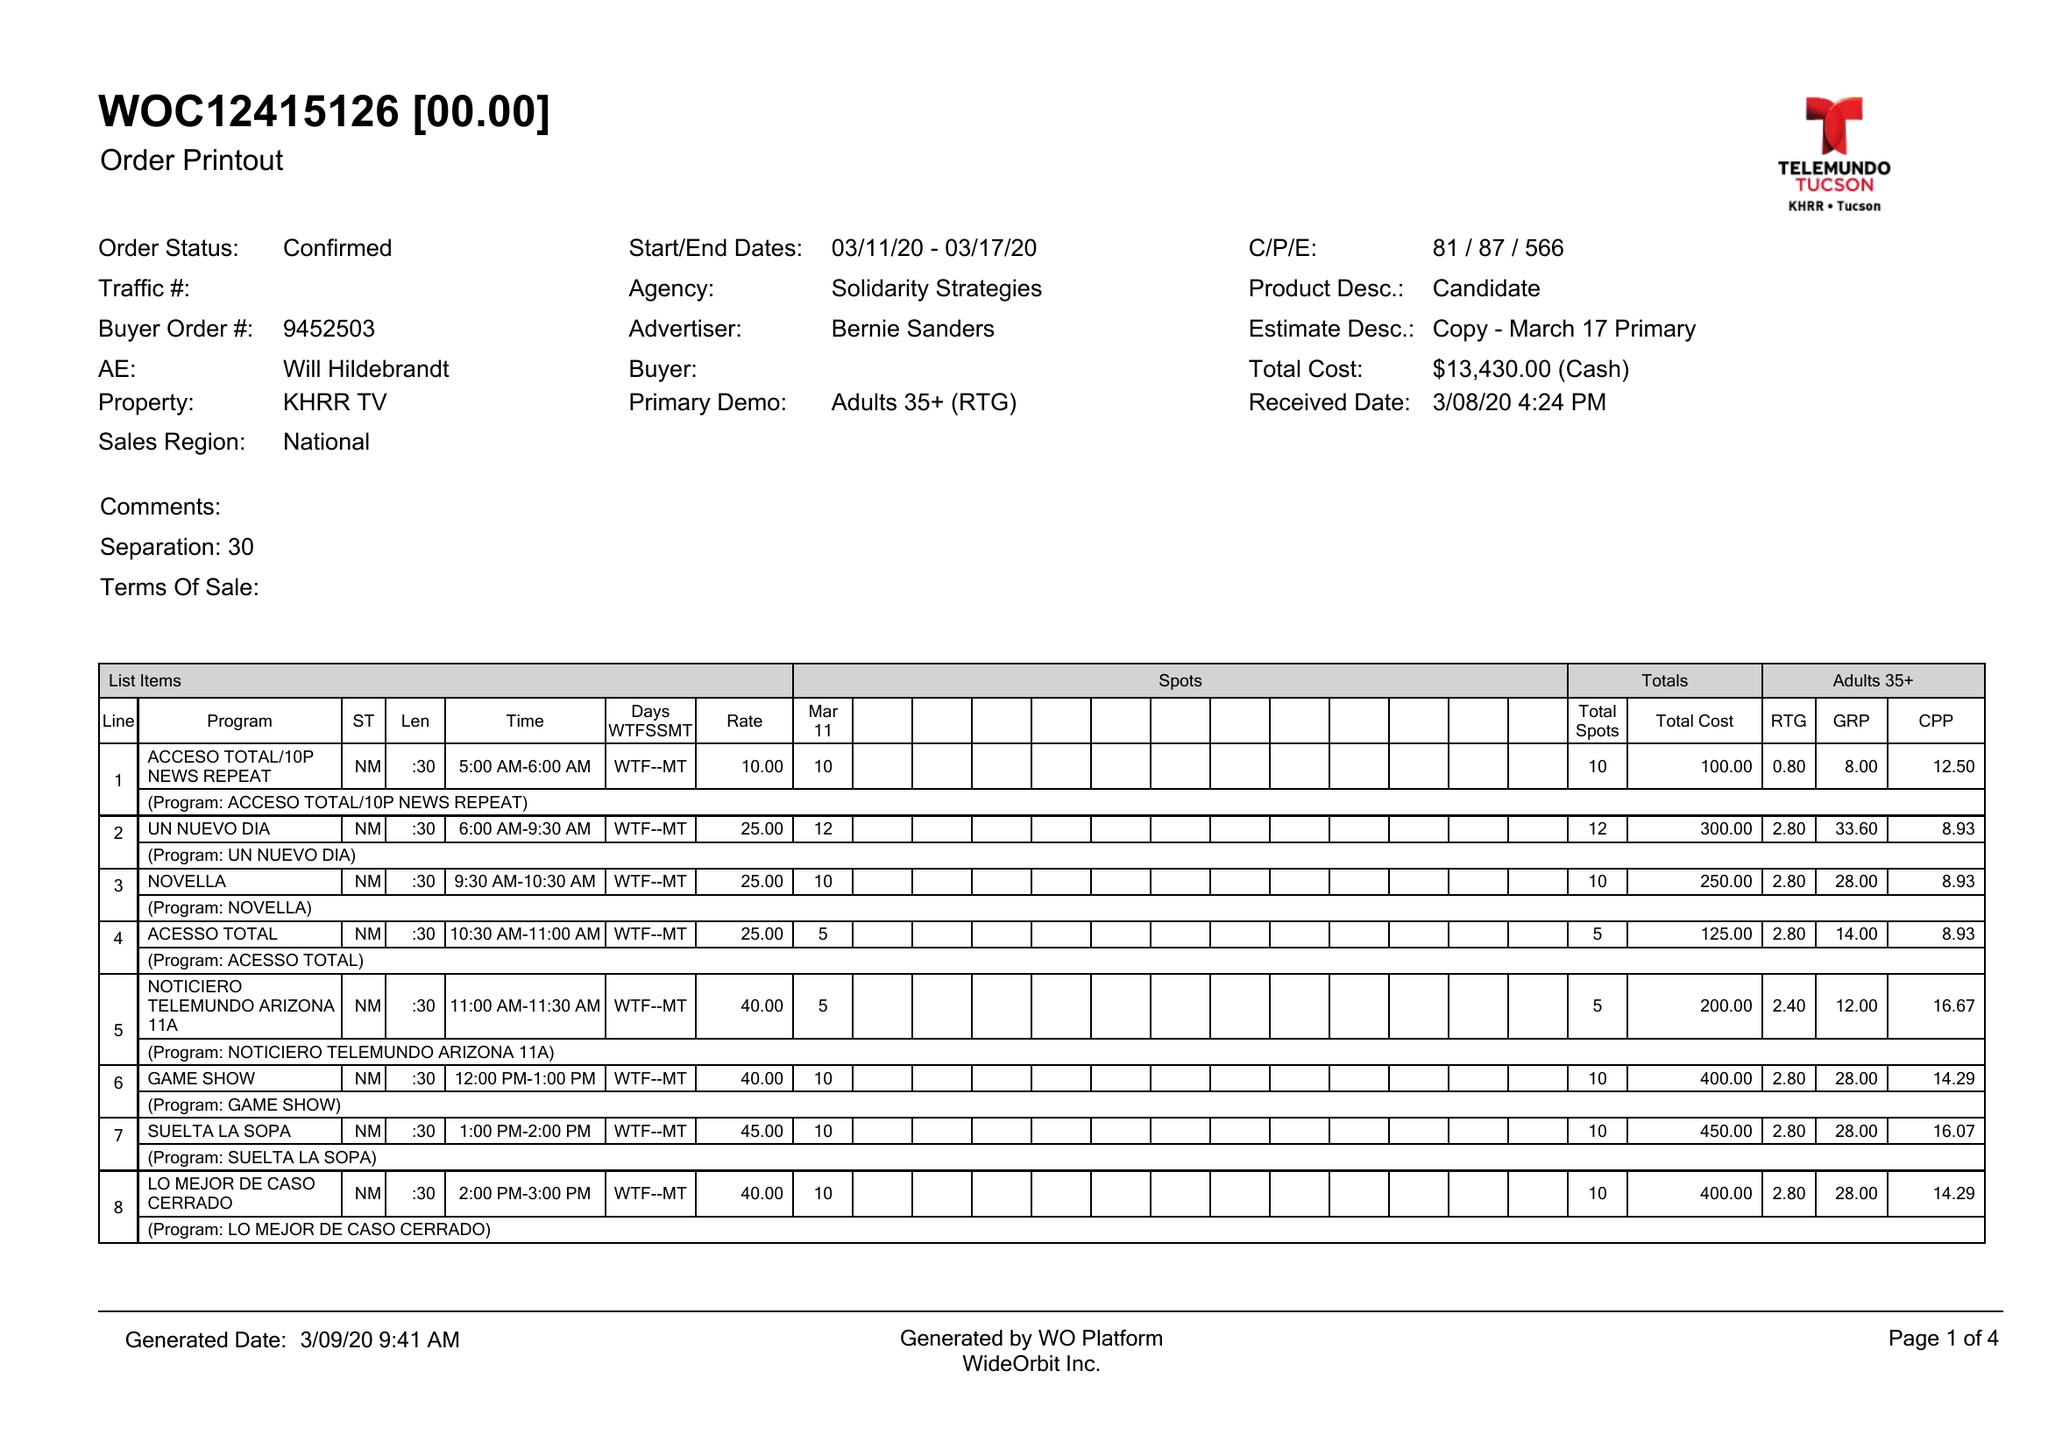What is the value for the gross_amount?
Answer the question using a single word or phrase. 13430.00 